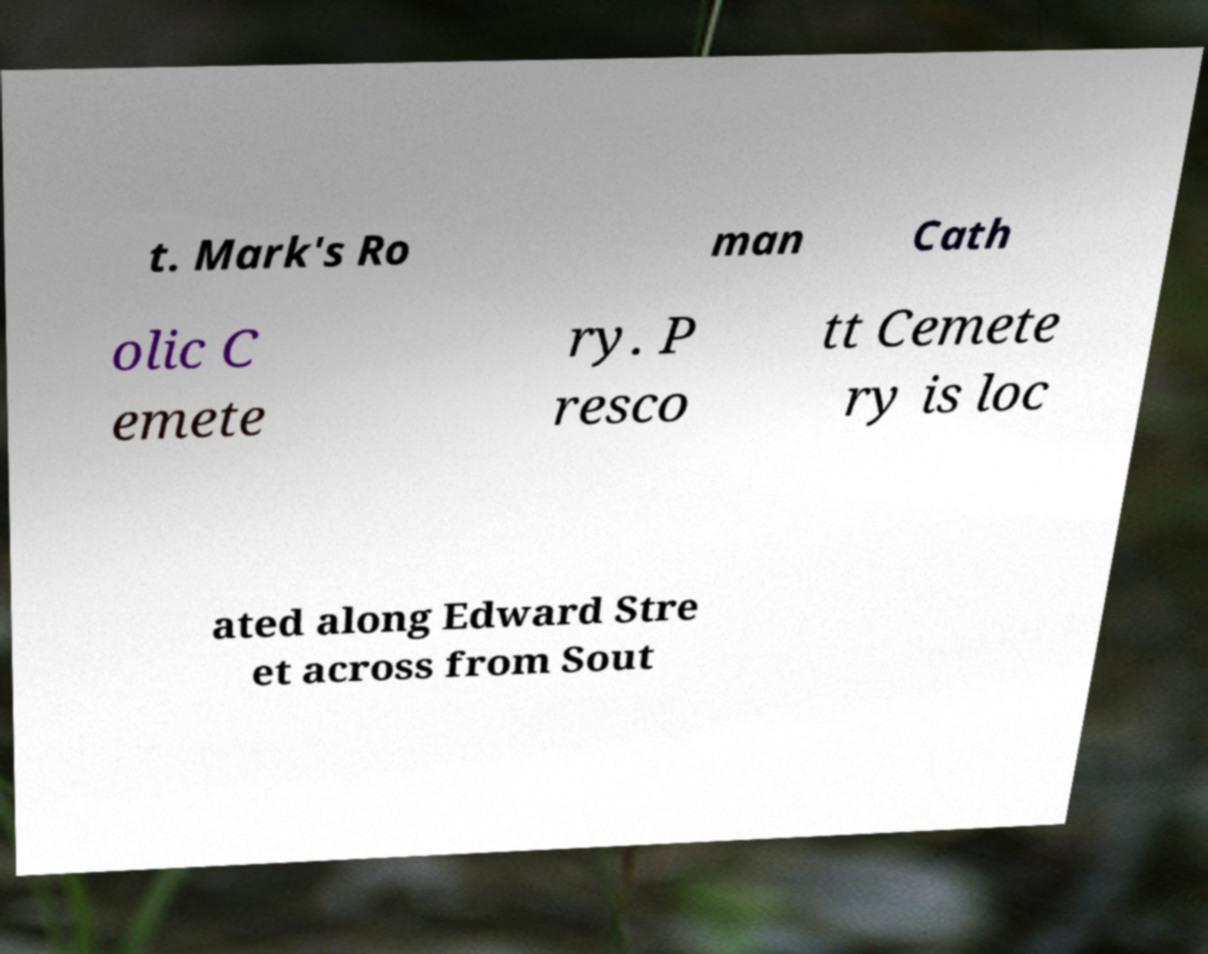I need the written content from this picture converted into text. Can you do that? t. Mark's Ro man Cath olic C emete ry. P resco tt Cemete ry is loc ated along Edward Stre et across from Sout 